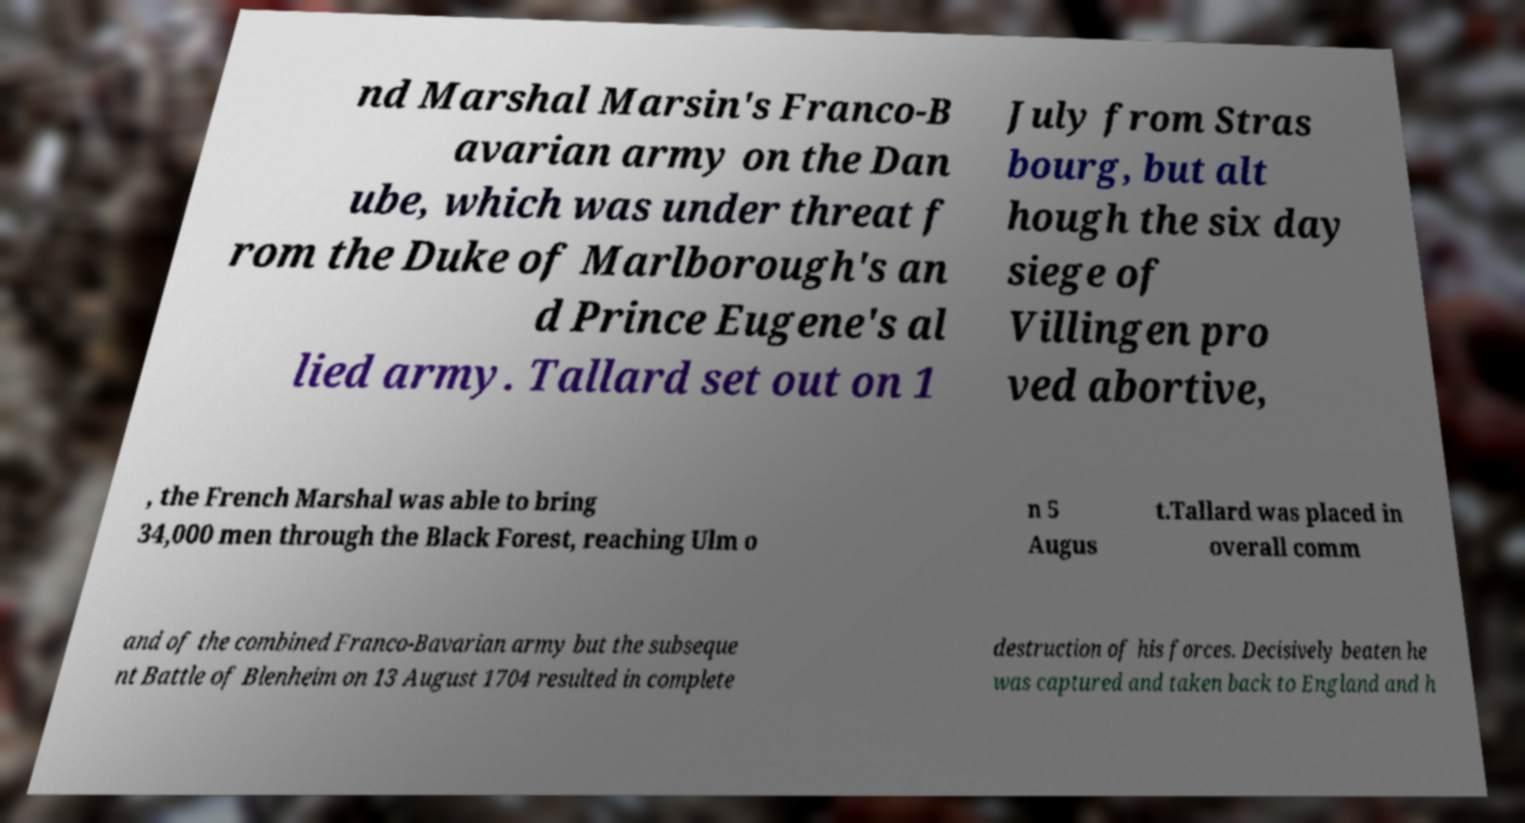Can you read and provide the text displayed in the image?This photo seems to have some interesting text. Can you extract and type it out for me? nd Marshal Marsin's Franco-B avarian army on the Dan ube, which was under threat f rom the Duke of Marlborough's an d Prince Eugene's al lied army. Tallard set out on 1 July from Stras bourg, but alt hough the six day siege of Villingen pro ved abortive, , the French Marshal was able to bring 34,000 men through the Black Forest, reaching Ulm o n 5 Augus t.Tallard was placed in overall comm and of the combined Franco-Bavarian army but the subseque nt Battle of Blenheim on 13 August 1704 resulted in complete destruction of his forces. Decisively beaten he was captured and taken back to England and h 